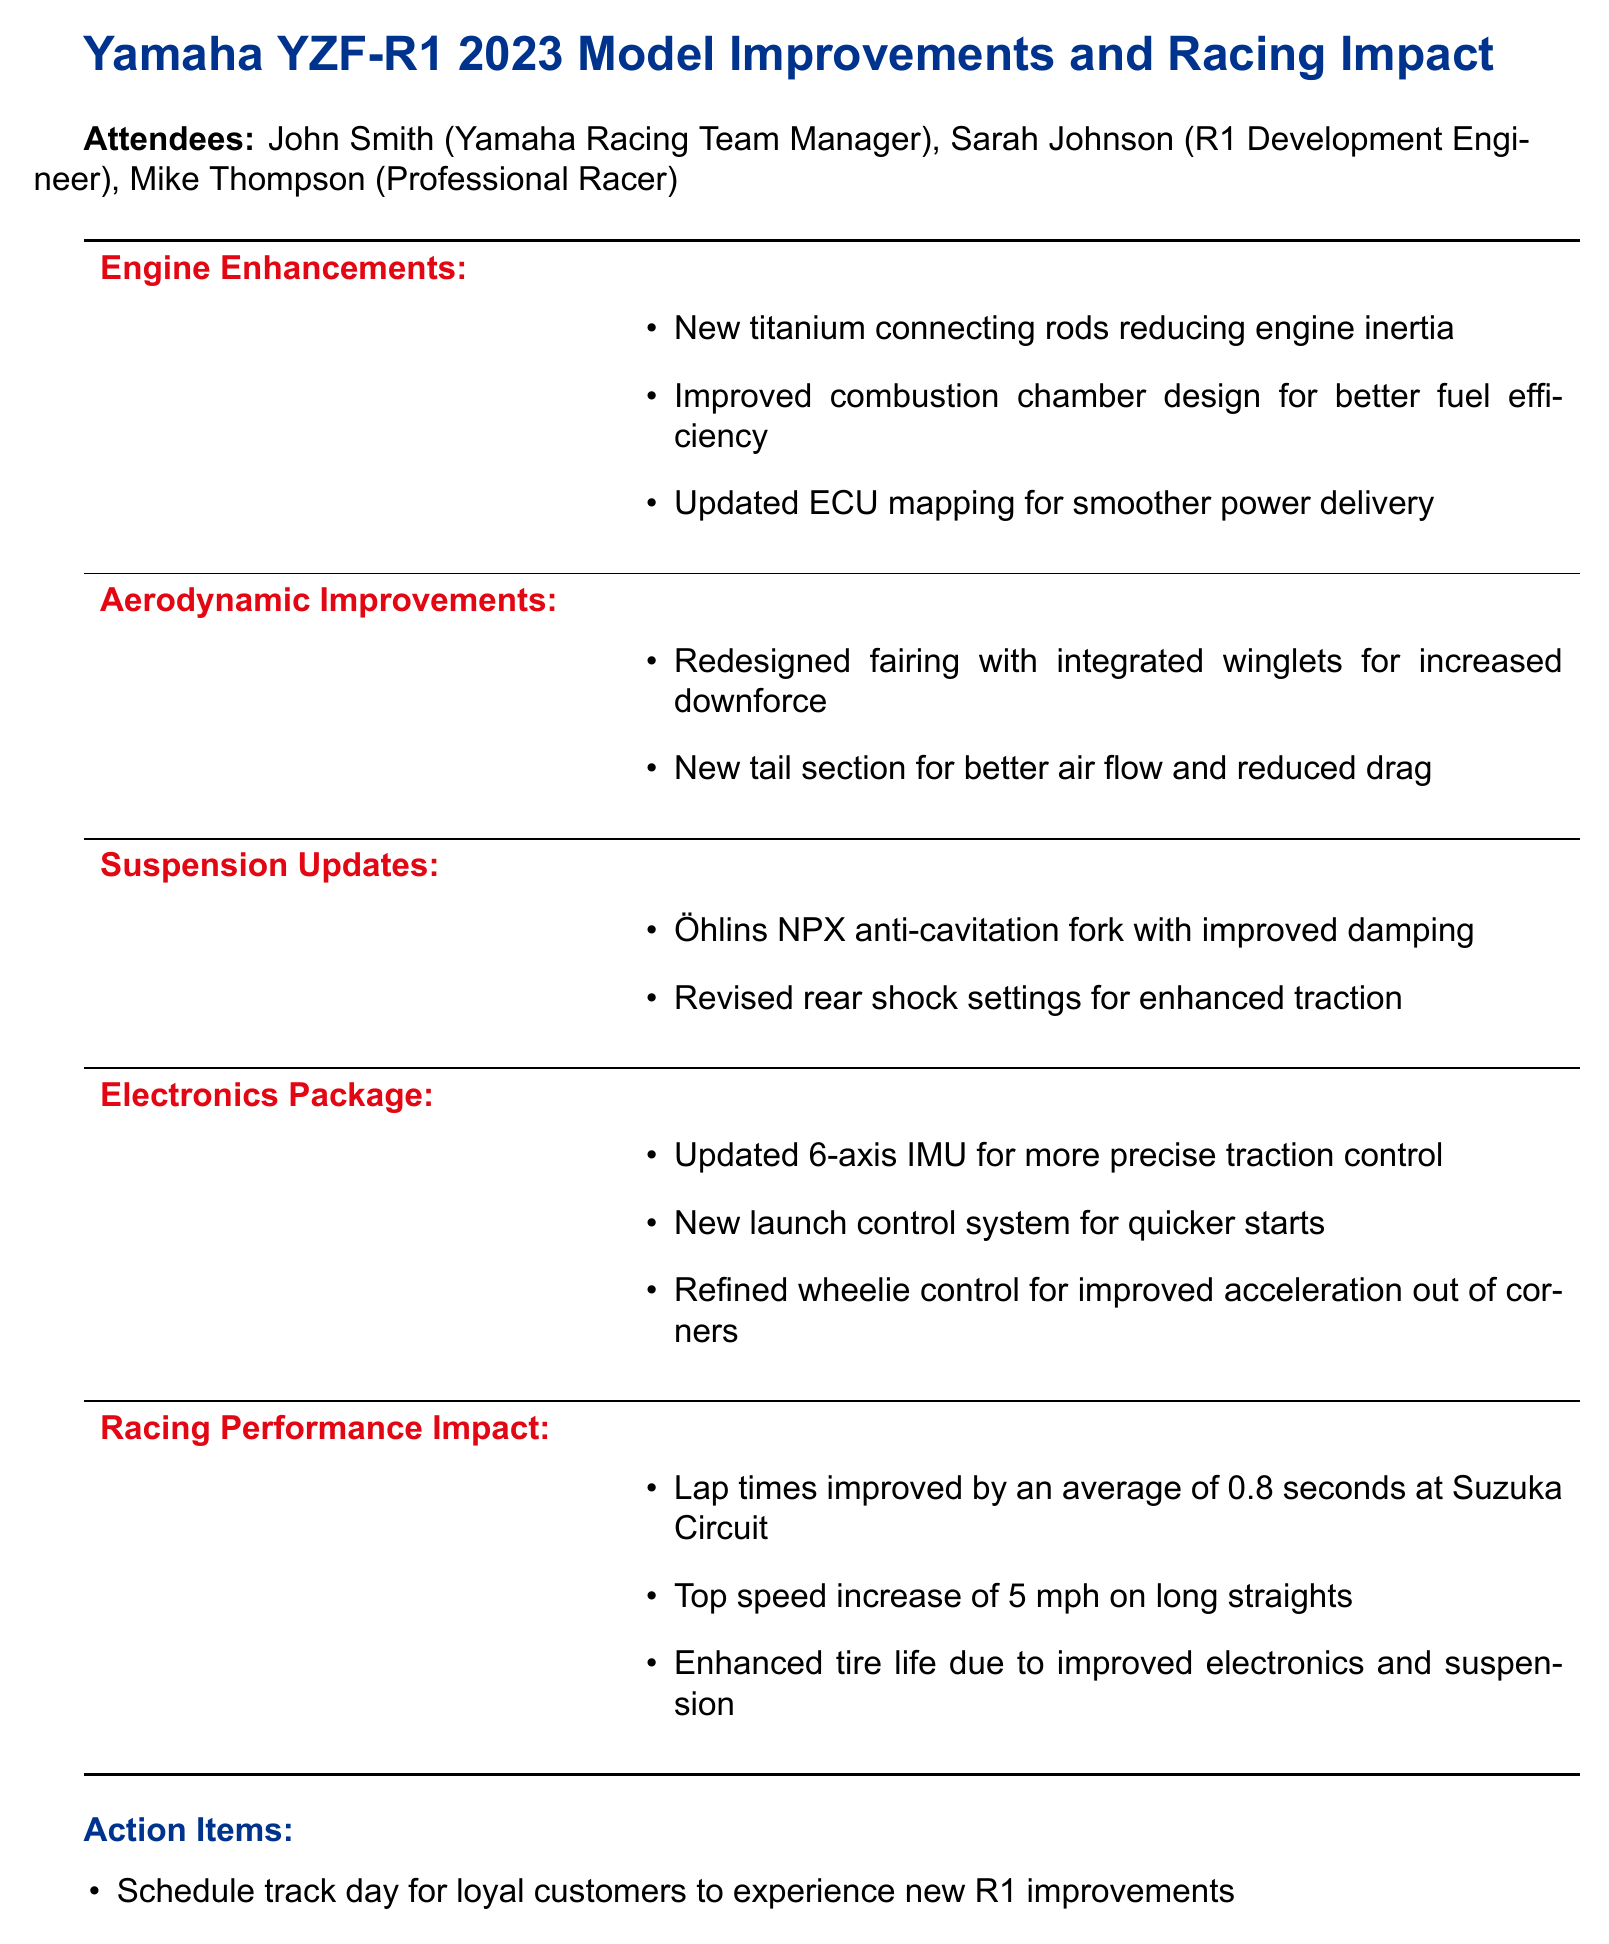What is the meeting date? The meeting date is clearly stated at the start of the document.
Answer: 2023-05-15 Who is the R1 Development Engineer? The document lists the attendees, including their roles.
Answer: Sarah Johnson What is one of the engine enhancements? The details of engine enhancements are listed in the agenda items.
Answer: New titanium connecting rods reducing engine inertia What improvement is mentioned for aerodynamics? The document outlines specific aerodynamic improvements in the meeting.
Answer: Redesigned fairing with integrated winglets for increased downforce How much were lap times improved at Suzuka Circuit? This performance impact is stated in the racing performance section.
Answer: 0.8 seconds What is the top speed increase reported? The top speed increase refers to the change in performance metrics discussed.
Answer: 5 mph What is one of the action items proposed? The action items summarize key follow-ups from the meeting.
Answer: Schedule track day for loyal customers to experience new R1 improvements What type of suspension update was mentioned? The specifics of the suspension updates are provided in the agenda items section.
Answer: Öhlins NPX anti-cavitation fork with improved damping 